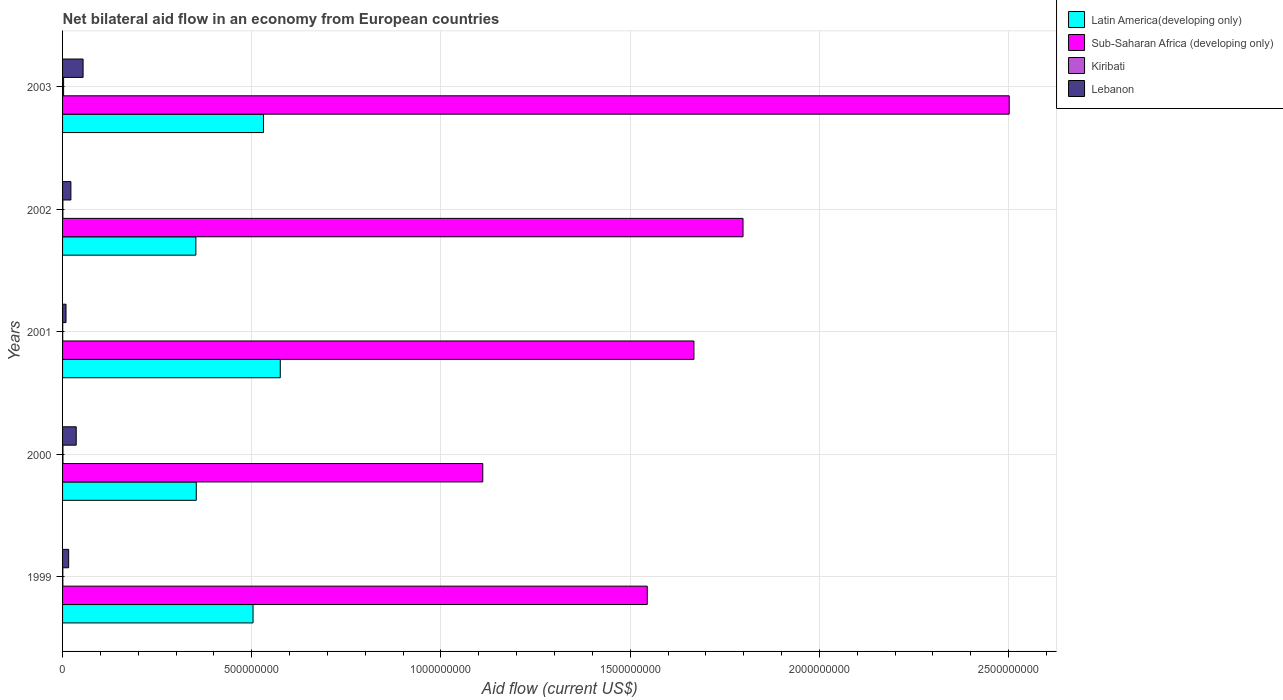How many groups of bars are there?
Make the answer very short. 5. Are the number of bars per tick equal to the number of legend labels?
Keep it short and to the point. Yes. Are the number of bars on each tick of the Y-axis equal?
Your response must be concise. Yes. What is the label of the 1st group of bars from the top?
Your response must be concise. 2003. In how many cases, is the number of bars for a given year not equal to the number of legend labels?
Your answer should be very brief. 0. What is the net bilateral aid flow in Latin America(developing only) in 2003?
Make the answer very short. 5.31e+08. Across all years, what is the maximum net bilateral aid flow in Latin America(developing only)?
Offer a very short reply. 5.75e+08. Across all years, what is the minimum net bilateral aid flow in Latin America(developing only)?
Your response must be concise. 3.52e+08. In which year was the net bilateral aid flow in Kiribati minimum?
Offer a terse response. 2001. What is the total net bilateral aid flow in Kiribati in the graph?
Give a very brief answer. 5.69e+06. What is the difference between the net bilateral aid flow in Latin America(developing only) in 2000 and that in 2002?
Provide a short and direct response. 1.07e+06. What is the difference between the net bilateral aid flow in Lebanon in 1999 and the net bilateral aid flow in Kiribati in 2003?
Ensure brevity in your answer.  1.34e+07. What is the average net bilateral aid flow in Lebanon per year?
Your response must be concise. 2.75e+07. In the year 2002, what is the difference between the net bilateral aid flow in Sub-Saharan Africa (developing only) and net bilateral aid flow in Lebanon?
Keep it short and to the point. 1.78e+09. In how many years, is the net bilateral aid flow in Latin America(developing only) greater than 1400000000 US$?
Provide a short and direct response. 0. What is the ratio of the net bilateral aid flow in Kiribati in 2001 to that in 2002?
Provide a short and direct response. 0.41. Is the net bilateral aid flow in Sub-Saharan Africa (developing only) in 1999 less than that in 2002?
Provide a short and direct response. Yes. What is the difference between the highest and the second highest net bilateral aid flow in Sub-Saharan Africa (developing only)?
Your answer should be very brief. 7.03e+08. What is the difference between the highest and the lowest net bilateral aid flow in Latin America(developing only)?
Offer a terse response. 2.23e+08. In how many years, is the net bilateral aid flow in Kiribati greater than the average net bilateral aid flow in Kiribati taken over all years?
Your response must be concise. 1. What does the 2nd bar from the top in 2000 represents?
Your answer should be very brief. Kiribati. What does the 2nd bar from the bottom in 2003 represents?
Give a very brief answer. Sub-Saharan Africa (developing only). Is it the case that in every year, the sum of the net bilateral aid flow in Sub-Saharan Africa (developing only) and net bilateral aid flow in Latin America(developing only) is greater than the net bilateral aid flow in Lebanon?
Keep it short and to the point. Yes. How many bars are there?
Offer a very short reply. 20. Are all the bars in the graph horizontal?
Provide a short and direct response. Yes. How many years are there in the graph?
Give a very brief answer. 5. What is the difference between two consecutive major ticks on the X-axis?
Make the answer very short. 5.00e+08. Does the graph contain any zero values?
Offer a very short reply. No. How many legend labels are there?
Make the answer very short. 4. What is the title of the graph?
Offer a terse response. Net bilateral aid flow in an economy from European countries. Does "Monaco" appear as one of the legend labels in the graph?
Your answer should be very brief. No. What is the label or title of the Y-axis?
Your answer should be very brief. Years. What is the Aid flow (current US$) of Latin America(developing only) in 1999?
Your response must be concise. 5.03e+08. What is the Aid flow (current US$) in Sub-Saharan Africa (developing only) in 1999?
Offer a very short reply. 1.55e+09. What is the Aid flow (current US$) of Kiribati in 1999?
Keep it short and to the point. 7.50e+05. What is the Aid flow (current US$) of Lebanon in 1999?
Provide a short and direct response. 1.61e+07. What is the Aid flow (current US$) of Latin America(developing only) in 2000?
Your answer should be very brief. 3.53e+08. What is the Aid flow (current US$) of Sub-Saharan Africa (developing only) in 2000?
Provide a succinct answer. 1.11e+09. What is the Aid flow (current US$) of Kiribati in 2000?
Your response must be concise. 1.01e+06. What is the Aid flow (current US$) of Lebanon in 2000?
Provide a short and direct response. 3.61e+07. What is the Aid flow (current US$) in Latin America(developing only) in 2001?
Make the answer very short. 5.75e+08. What is the Aid flow (current US$) in Sub-Saharan Africa (developing only) in 2001?
Your answer should be very brief. 1.67e+09. What is the Aid flow (current US$) in Kiribati in 2001?
Offer a very short reply. 3.50e+05. What is the Aid flow (current US$) in Lebanon in 2001?
Offer a terse response. 9.12e+06. What is the Aid flow (current US$) in Latin America(developing only) in 2002?
Your answer should be compact. 3.52e+08. What is the Aid flow (current US$) of Sub-Saharan Africa (developing only) in 2002?
Ensure brevity in your answer.  1.80e+09. What is the Aid flow (current US$) in Kiribati in 2002?
Your response must be concise. 8.50e+05. What is the Aid flow (current US$) of Lebanon in 2002?
Ensure brevity in your answer.  2.20e+07. What is the Aid flow (current US$) of Latin America(developing only) in 2003?
Offer a very short reply. 5.31e+08. What is the Aid flow (current US$) in Sub-Saharan Africa (developing only) in 2003?
Offer a very short reply. 2.50e+09. What is the Aid flow (current US$) in Kiribati in 2003?
Keep it short and to the point. 2.73e+06. What is the Aid flow (current US$) in Lebanon in 2003?
Provide a succinct answer. 5.43e+07. Across all years, what is the maximum Aid flow (current US$) in Latin America(developing only)?
Keep it short and to the point. 5.75e+08. Across all years, what is the maximum Aid flow (current US$) of Sub-Saharan Africa (developing only)?
Offer a terse response. 2.50e+09. Across all years, what is the maximum Aid flow (current US$) in Kiribati?
Your answer should be compact. 2.73e+06. Across all years, what is the maximum Aid flow (current US$) in Lebanon?
Ensure brevity in your answer.  5.43e+07. Across all years, what is the minimum Aid flow (current US$) in Latin America(developing only)?
Offer a terse response. 3.52e+08. Across all years, what is the minimum Aid flow (current US$) of Sub-Saharan Africa (developing only)?
Your response must be concise. 1.11e+09. Across all years, what is the minimum Aid flow (current US$) of Lebanon?
Provide a short and direct response. 9.12e+06. What is the total Aid flow (current US$) in Latin America(developing only) in the graph?
Provide a succinct answer. 2.32e+09. What is the total Aid flow (current US$) of Sub-Saharan Africa (developing only) in the graph?
Offer a terse response. 8.62e+09. What is the total Aid flow (current US$) of Kiribati in the graph?
Your answer should be very brief. 5.69e+06. What is the total Aid flow (current US$) of Lebanon in the graph?
Make the answer very short. 1.38e+08. What is the difference between the Aid flow (current US$) in Latin America(developing only) in 1999 and that in 2000?
Keep it short and to the point. 1.50e+08. What is the difference between the Aid flow (current US$) of Sub-Saharan Africa (developing only) in 1999 and that in 2000?
Keep it short and to the point. 4.35e+08. What is the difference between the Aid flow (current US$) of Lebanon in 1999 and that in 2000?
Make the answer very short. -2.00e+07. What is the difference between the Aid flow (current US$) of Latin America(developing only) in 1999 and that in 2001?
Your answer should be compact. -7.20e+07. What is the difference between the Aid flow (current US$) of Sub-Saharan Africa (developing only) in 1999 and that in 2001?
Ensure brevity in your answer.  -1.23e+08. What is the difference between the Aid flow (current US$) of Kiribati in 1999 and that in 2001?
Offer a very short reply. 4.00e+05. What is the difference between the Aid flow (current US$) in Lebanon in 1999 and that in 2001?
Your answer should be very brief. 6.97e+06. What is the difference between the Aid flow (current US$) in Latin America(developing only) in 1999 and that in 2002?
Provide a succinct answer. 1.51e+08. What is the difference between the Aid flow (current US$) in Sub-Saharan Africa (developing only) in 1999 and that in 2002?
Your answer should be compact. -2.53e+08. What is the difference between the Aid flow (current US$) in Kiribati in 1999 and that in 2002?
Your response must be concise. -1.00e+05. What is the difference between the Aid flow (current US$) in Lebanon in 1999 and that in 2002?
Keep it short and to the point. -5.90e+06. What is the difference between the Aid flow (current US$) in Latin America(developing only) in 1999 and that in 2003?
Offer a terse response. -2.76e+07. What is the difference between the Aid flow (current US$) of Sub-Saharan Africa (developing only) in 1999 and that in 2003?
Your response must be concise. -9.57e+08. What is the difference between the Aid flow (current US$) of Kiribati in 1999 and that in 2003?
Make the answer very short. -1.98e+06. What is the difference between the Aid flow (current US$) in Lebanon in 1999 and that in 2003?
Provide a short and direct response. -3.82e+07. What is the difference between the Aid flow (current US$) of Latin America(developing only) in 2000 and that in 2001?
Make the answer very short. -2.22e+08. What is the difference between the Aid flow (current US$) of Sub-Saharan Africa (developing only) in 2000 and that in 2001?
Provide a succinct answer. -5.58e+08. What is the difference between the Aid flow (current US$) of Kiribati in 2000 and that in 2001?
Give a very brief answer. 6.60e+05. What is the difference between the Aid flow (current US$) in Lebanon in 2000 and that in 2001?
Your response must be concise. 2.70e+07. What is the difference between the Aid flow (current US$) of Latin America(developing only) in 2000 and that in 2002?
Keep it short and to the point. 1.07e+06. What is the difference between the Aid flow (current US$) of Sub-Saharan Africa (developing only) in 2000 and that in 2002?
Ensure brevity in your answer.  -6.88e+08. What is the difference between the Aid flow (current US$) of Kiribati in 2000 and that in 2002?
Your answer should be very brief. 1.60e+05. What is the difference between the Aid flow (current US$) of Lebanon in 2000 and that in 2002?
Make the answer very short. 1.41e+07. What is the difference between the Aid flow (current US$) of Latin America(developing only) in 2000 and that in 2003?
Your answer should be compact. -1.78e+08. What is the difference between the Aid flow (current US$) in Sub-Saharan Africa (developing only) in 2000 and that in 2003?
Your answer should be compact. -1.39e+09. What is the difference between the Aid flow (current US$) of Kiribati in 2000 and that in 2003?
Make the answer very short. -1.72e+06. What is the difference between the Aid flow (current US$) of Lebanon in 2000 and that in 2003?
Your response must be concise. -1.82e+07. What is the difference between the Aid flow (current US$) in Latin America(developing only) in 2001 and that in 2002?
Make the answer very short. 2.23e+08. What is the difference between the Aid flow (current US$) in Sub-Saharan Africa (developing only) in 2001 and that in 2002?
Give a very brief answer. -1.30e+08. What is the difference between the Aid flow (current US$) in Kiribati in 2001 and that in 2002?
Your answer should be very brief. -5.00e+05. What is the difference between the Aid flow (current US$) of Lebanon in 2001 and that in 2002?
Give a very brief answer. -1.29e+07. What is the difference between the Aid flow (current US$) of Latin America(developing only) in 2001 and that in 2003?
Make the answer very short. 4.44e+07. What is the difference between the Aid flow (current US$) in Sub-Saharan Africa (developing only) in 2001 and that in 2003?
Offer a very short reply. -8.33e+08. What is the difference between the Aid flow (current US$) of Kiribati in 2001 and that in 2003?
Provide a succinct answer. -2.38e+06. What is the difference between the Aid flow (current US$) in Lebanon in 2001 and that in 2003?
Your response must be concise. -4.51e+07. What is the difference between the Aid flow (current US$) of Latin America(developing only) in 2002 and that in 2003?
Your answer should be very brief. -1.79e+08. What is the difference between the Aid flow (current US$) in Sub-Saharan Africa (developing only) in 2002 and that in 2003?
Offer a terse response. -7.03e+08. What is the difference between the Aid flow (current US$) of Kiribati in 2002 and that in 2003?
Keep it short and to the point. -1.88e+06. What is the difference between the Aid flow (current US$) of Lebanon in 2002 and that in 2003?
Give a very brief answer. -3.23e+07. What is the difference between the Aid flow (current US$) in Latin America(developing only) in 1999 and the Aid flow (current US$) in Sub-Saharan Africa (developing only) in 2000?
Provide a short and direct response. -6.07e+08. What is the difference between the Aid flow (current US$) in Latin America(developing only) in 1999 and the Aid flow (current US$) in Kiribati in 2000?
Provide a succinct answer. 5.02e+08. What is the difference between the Aid flow (current US$) of Latin America(developing only) in 1999 and the Aid flow (current US$) of Lebanon in 2000?
Provide a succinct answer. 4.67e+08. What is the difference between the Aid flow (current US$) of Sub-Saharan Africa (developing only) in 1999 and the Aid flow (current US$) of Kiribati in 2000?
Offer a terse response. 1.54e+09. What is the difference between the Aid flow (current US$) in Sub-Saharan Africa (developing only) in 1999 and the Aid flow (current US$) in Lebanon in 2000?
Your answer should be compact. 1.51e+09. What is the difference between the Aid flow (current US$) in Kiribati in 1999 and the Aid flow (current US$) in Lebanon in 2000?
Offer a very short reply. -3.53e+07. What is the difference between the Aid flow (current US$) of Latin America(developing only) in 1999 and the Aid flow (current US$) of Sub-Saharan Africa (developing only) in 2001?
Keep it short and to the point. -1.17e+09. What is the difference between the Aid flow (current US$) in Latin America(developing only) in 1999 and the Aid flow (current US$) in Kiribati in 2001?
Provide a short and direct response. 5.03e+08. What is the difference between the Aid flow (current US$) in Latin America(developing only) in 1999 and the Aid flow (current US$) in Lebanon in 2001?
Offer a very short reply. 4.94e+08. What is the difference between the Aid flow (current US$) of Sub-Saharan Africa (developing only) in 1999 and the Aid flow (current US$) of Kiribati in 2001?
Give a very brief answer. 1.54e+09. What is the difference between the Aid flow (current US$) in Sub-Saharan Africa (developing only) in 1999 and the Aid flow (current US$) in Lebanon in 2001?
Provide a short and direct response. 1.54e+09. What is the difference between the Aid flow (current US$) of Kiribati in 1999 and the Aid flow (current US$) of Lebanon in 2001?
Offer a very short reply. -8.37e+06. What is the difference between the Aid flow (current US$) of Latin America(developing only) in 1999 and the Aid flow (current US$) of Sub-Saharan Africa (developing only) in 2002?
Provide a short and direct response. -1.29e+09. What is the difference between the Aid flow (current US$) of Latin America(developing only) in 1999 and the Aid flow (current US$) of Kiribati in 2002?
Your answer should be compact. 5.03e+08. What is the difference between the Aid flow (current US$) of Latin America(developing only) in 1999 and the Aid flow (current US$) of Lebanon in 2002?
Your answer should be compact. 4.81e+08. What is the difference between the Aid flow (current US$) in Sub-Saharan Africa (developing only) in 1999 and the Aid flow (current US$) in Kiribati in 2002?
Your response must be concise. 1.54e+09. What is the difference between the Aid flow (current US$) in Sub-Saharan Africa (developing only) in 1999 and the Aid flow (current US$) in Lebanon in 2002?
Keep it short and to the point. 1.52e+09. What is the difference between the Aid flow (current US$) in Kiribati in 1999 and the Aid flow (current US$) in Lebanon in 2002?
Offer a terse response. -2.12e+07. What is the difference between the Aid flow (current US$) of Latin America(developing only) in 1999 and the Aid flow (current US$) of Sub-Saharan Africa (developing only) in 2003?
Your response must be concise. -2.00e+09. What is the difference between the Aid flow (current US$) in Latin America(developing only) in 1999 and the Aid flow (current US$) in Kiribati in 2003?
Provide a succinct answer. 5.01e+08. What is the difference between the Aid flow (current US$) of Latin America(developing only) in 1999 and the Aid flow (current US$) of Lebanon in 2003?
Your answer should be very brief. 4.49e+08. What is the difference between the Aid flow (current US$) in Sub-Saharan Africa (developing only) in 1999 and the Aid flow (current US$) in Kiribati in 2003?
Your answer should be compact. 1.54e+09. What is the difference between the Aid flow (current US$) in Sub-Saharan Africa (developing only) in 1999 and the Aid flow (current US$) in Lebanon in 2003?
Provide a short and direct response. 1.49e+09. What is the difference between the Aid flow (current US$) of Kiribati in 1999 and the Aid flow (current US$) of Lebanon in 2003?
Offer a terse response. -5.35e+07. What is the difference between the Aid flow (current US$) of Latin America(developing only) in 2000 and the Aid flow (current US$) of Sub-Saharan Africa (developing only) in 2001?
Provide a succinct answer. -1.32e+09. What is the difference between the Aid flow (current US$) of Latin America(developing only) in 2000 and the Aid flow (current US$) of Kiribati in 2001?
Your answer should be very brief. 3.53e+08. What is the difference between the Aid flow (current US$) in Latin America(developing only) in 2000 and the Aid flow (current US$) in Lebanon in 2001?
Offer a very short reply. 3.44e+08. What is the difference between the Aid flow (current US$) of Sub-Saharan Africa (developing only) in 2000 and the Aid flow (current US$) of Kiribati in 2001?
Ensure brevity in your answer.  1.11e+09. What is the difference between the Aid flow (current US$) of Sub-Saharan Africa (developing only) in 2000 and the Aid flow (current US$) of Lebanon in 2001?
Your answer should be compact. 1.10e+09. What is the difference between the Aid flow (current US$) in Kiribati in 2000 and the Aid flow (current US$) in Lebanon in 2001?
Provide a succinct answer. -8.11e+06. What is the difference between the Aid flow (current US$) of Latin America(developing only) in 2000 and the Aid flow (current US$) of Sub-Saharan Africa (developing only) in 2002?
Your answer should be compact. -1.44e+09. What is the difference between the Aid flow (current US$) in Latin America(developing only) in 2000 and the Aid flow (current US$) in Kiribati in 2002?
Give a very brief answer. 3.53e+08. What is the difference between the Aid flow (current US$) in Latin America(developing only) in 2000 and the Aid flow (current US$) in Lebanon in 2002?
Give a very brief answer. 3.31e+08. What is the difference between the Aid flow (current US$) of Sub-Saharan Africa (developing only) in 2000 and the Aid flow (current US$) of Kiribati in 2002?
Provide a succinct answer. 1.11e+09. What is the difference between the Aid flow (current US$) of Sub-Saharan Africa (developing only) in 2000 and the Aid flow (current US$) of Lebanon in 2002?
Offer a terse response. 1.09e+09. What is the difference between the Aid flow (current US$) of Kiribati in 2000 and the Aid flow (current US$) of Lebanon in 2002?
Offer a very short reply. -2.10e+07. What is the difference between the Aid flow (current US$) in Latin America(developing only) in 2000 and the Aid flow (current US$) in Sub-Saharan Africa (developing only) in 2003?
Keep it short and to the point. -2.15e+09. What is the difference between the Aid flow (current US$) in Latin America(developing only) in 2000 and the Aid flow (current US$) in Kiribati in 2003?
Offer a very short reply. 3.51e+08. What is the difference between the Aid flow (current US$) of Latin America(developing only) in 2000 and the Aid flow (current US$) of Lebanon in 2003?
Your answer should be compact. 2.99e+08. What is the difference between the Aid flow (current US$) in Sub-Saharan Africa (developing only) in 2000 and the Aid flow (current US$) in Kiribati in 2003?
Give a very brief answer. 1.11e+09. What is the difference between the Aid flow (current US$) of Sub-Saharan Africa (developing only) in 2000 and the Aid flow (current US$) of Lebanon in 2003?
Give a very brief answer. 1.06e+09. What is the difference between the Aid flow (current US$) of Kiribati in 2000 and the Aid flow (current US$) of Lebanon in 2003?
Your response must be concise. -5.32e+07. What is the difference between the Aid flow (current US$) in Latin America(developing only) in 2001 and the Aid flow (current US$) in Sub-Saharan Africa (developing only) in 2002?
Offer a very short reply. -1.22e+09. What is the difference between the Aid flow (current US$) in Latin America(developing only) in 2001 and the Aid flow (current US$) in Kiribati in 2002?
Offer a very short reply. 5.75e+08. What is the difference between the Aid flow (current US$) of Latin America(developing only) in 2001 and the Aid flow (current US$) of Lebanon in 2002?
Your answer should be very brief. 5.53e+08. What is the difference between the Aid flow (current US$) of Sub-Saharan Africa (developing only) in 2001 and the Aid flow (current US$) of Kiribati in 2002?
Make the answer very short. 1.67e+09. What is the difference between the Aid flow (current US$) in Sub-Saharan Africa (developing only) in 2001 and the Aid flow (current US$) in Lebanon in 2002?
Make the answer very short. 1.65e+09. What is the difference between the Aid flow (current US$) in Kiribati in 2001 and the Aid flow (current US$) in Lebanon in 2002?
Make the answer very short. -2.16e+07. What is the difference between the Aid flow (current US$) in Latin America(developing only) in 2001 and the Aid flow (current US$) in Sub-Saharan Africa (developing only) in 2003?
Provide a succinct answer. -1.93e+09. What is the difference between the Aid flow (current US$) of Latin America(developing only) in 2001 and the Aid flow (current US$) of Kiribati in 2003?
Your answer should be compact. 5.73e+08. What is the difference between the Aid flow (current US$) of Latin America(developing only) in 2001 and the Aid flow (current US$) of Lebanon in 2003?
Ensure brevity in your answer.  5.21e+08. What is the difference between the Aid flow (current US$) in Sub-Saharan Africa (developing only) in 2001 and the Aid flow (current US$) in Kiribati in 2003?
Offer a terse response. 1.67e+09. What is the difference between the Aid flow (current US$) in Sub-Saharan Africa (developing only) in 2001 and the Aid flow (current US$) in Lebanon in 2003?
Provide a succinct answer. 1.61e+09. What is the difference between the Aid flow (current US$) of Kiribati in 2001 and the Aid flow (current US$) of Lebanon in 2003?
Provide a short and direct response. -5.39e+07. What is the difference between the Aid flow (current US$) in Latin America(developing only) in 2002 and the Aid flow (current US$) in Sub-Saharan Africa (developing only) in 2003?
Your answer should be compact. -2.15e+09. What is the difference between the Aid flow (current US$) in Latin America(developing only) in 2002 and the Aid flow (current US$) in Kiribati in 2003?
Provide a succinct answer. 3.50e+08. What is the difference between the Aid flow (current US$) of Latin America(developing only) in 2002 and the Aid flow (current US$) of Lebanon in 2003?
Your answer should be compact. 2.98e+08. What is the difference between the Aid flow (current US$) of Sub-Saharan Africa (developing only) in 2002 and the Aid flow (current US$) of Kiribati in 2003?
Your response must be concise. 1.80e+09. What is the difference between the Aid flow (current US$) in Sub-Saharan Africa (developing only) in 2002 and the Aid flow (current US$) in Lebanon in 2003?
Your answer should be very brief. 1.74e+09. What is the difference between the Aid flow (current US$) of Kiribati in 2002 and the Aid flow (current US$) of Lebanon in 2003?
Provide a short and direct response. -5.34e+07. What is the average Aid flow (current US$) in Latin America(developing only) per year?
Provide a short and direct response. 4.63e+08. What is the average Aid flow (current US$) of Sub-Saharan Africa (developing only) per year?
Provide a succinct answer. 1.72e+09. What is the average Aid flow (current US$) of Kiribati per year?
Provide a succinct answer. 1.14e+06. What is the average Aid flow (current US$) of Lebanon per year?
Ensure brevity in your answer.  2.75e+07. In the year 1999, what is the difference between the Aid flow (current US$) in Latin America(developing only) and Aid flow (current US$) in Sub-Saharan Africa (developing only)?
Provide a succinct answer. -1.04e+09. In the year 1999, what is the difference between the Aid flow (current US$) of Latin America(developing only) and Aid flow (current US$) of Kiribati?
Your answer should be compact. 5.03e+08. In the year 1999, what is the difference between the Aid flow (current US$) in Latin America(developing only) and Aid flow (current US$) in Lebanon?
Give a very brief answer. 4.87e+08. In the year 1999, what is the difference between the Aid flow (current US$) in Sub-Saharan Africa (developing only) and Aid flow (current US$) in Kiribati?
Provide a succinct answer. 1.54e+09. In the year 1999, what is the difference between the Aid flow (current US$) in Sub-Saharan Africa (developing only) and Aid flow (current US$) in Lebanon?
Give a very brief answer. 1.53e+09. In the year 1999, what is the difference between the Aid flow (current US$) of Kiribati and Aid flow (current US$) of Lebanon?
Your response must be concise. -1.53e+07. In the year 2000, what is the difference between the Aid flow (current US$) in Latin America(developing only) and Aid flow (current US$) in Sub-Saharan Africa (developing only)?
Make the answer very short. -7.57e+08. In the year 2000, what is the difference between the Aid flow (current US$) of Latin America(developing only) and Aid flow (current US$) of Kiribati?
Provide a short and direct response. 3.52e+08. In the year 2000, what is the difference between the Aid flow (current US$) in Latin America(developing only) and Aid flow (current US$) in Lebanon?
Your answer should be very brief. 3.17e+08. In the year 2000, what is the difference between the Aid flow (current US$) of Sub-Saharan Africa (developing only) and Aid flow (current US$) of Kiribati?
Make the answer very short. 1.11e+09. In the year 2000, what is the difference between the Aid flow (current US$) of Sub-Saharan Africa (developing only) and Aid flow (current US$) of Lebanon?
Offer a very short reply. 1.07e+09. In the year 2000, what is the difference between the Aid flow (current US$) of Kiribati and Aid flow (current US$) of Lebanon?
Your response must be concise. -3.51e+07. In the year 2001, what is the difference between the Aid flow (current US$) of Latin America(developing only) and Aid flow (current US$) of Sub-Saharan Africa (developing only)?
Keep it short and to the point. -1.09e+09. In the year 2001, what is the difference between the Aid flow (current US$) in Latin America(developing only) and Aid flow (current US$) in Kiribati?
Provide a succinct answer. 5.75e+08. In the year 2001, what is the difference between the Aid flow (current US$) of Latin America(developing only) and Aid flow (current US$) of Lebanon?
Offer a very short reply. 5.66e+08. In the year 2001, what is the difference between the Aid flow (current US$) of Sub-Saharan Africa (developing only) and Aid flow (current US$) of Kiribati?
Keep it short and to the point. 1.67e+09. In the year 2001, what is the difference between the Aid flow (current US$) of Sub-Saharan Africa (developing only) and Aid flow (current US$) of Lebanon?
Your response must be concise. 1.66e+09. In the year 2001, what is the difference between the Aid flow (current US$) of Kiribati and Aid flow (current US$) of Lebanon?
Give a very brief answer. -8.77e+06. In the year 2002, what is the difference between the Aid flow (current US$) of Latin America(developing only) and Aid flow (current US$) of Sub-Saharan Africa (developing only)?
Your answer should be compact. -1.45e+09. In the year 2002, what is the difference between the Aid flow (current US$) in Latin America(developing only) and Aid flow (current US$) in Kiribati?
Your answer should be very brief. 3.51e+08. In the year 2002, what is the difference between the Aid flow (current US$) of Latin America(developing only) and Aid flow (current US$) of Lebanon?
Provide a short and direct response. 3.30e+08. In the year 2002, what is the difference between the Aid flow (current US$) of Sub-Saharan Africa (developing only) and Aid flow (current US$) of Kiribati?
Offer a very short reply. 1.80e+09. In the year 2002, what is the difference between the Aid flow (current US$) in Sub-Saharan Africa (developing only) and Aid flow (current US$) in Lebanon?
Keep it short and to the point. 1.78e+09. In the year 2002, what is the difference between the Aid flow (current US$) of Kiribati and Aid flow (current US$) of Lebanon?
Offer a terse response. -2.11e+07. In the year 2003, what is the difference between the Aid flow (current US$) in Latin America(developing only) and Aid flow (current US$) in Sub-Saharan Africa (developing only)?
Give a very brief answer. -1.97e+09. In the year 2003, what is the difference between the Aid flow (current US$) in Latin America(developing only) and Aid flow (current US$) in Kiribati?
Ensure brevity in your answer.  5.28e+08. In the year 2003, what is the difference between the Aid flow (current US$) of Latin America(developing only) and Aid flow (current US$) of Lebanon?
Keep it short and to the point. 4.77e+08. In the year 2003, what is the difference between the Aid flow (current US$) in Sub-Saharan Africa (developing only) and Aid flow (current US$) in Kiribati?
Provide a succinct answer. 2.50e+09. In the year 2003, what is the difference between the Aid flow (current US$) in Sub-Saharan Africa (developing only) and Aid flow (current US$) in Lebanon?
Keep it short and to the point. 2.45e+09. In the year 2003, what is the difference between the Aid flow (current US$) in Kiribati and Aid flow (current US$) in Lebanon?
Give a very brief answer. -5.15e+07. What is the ratio of the Aid flow (current US$) of Latin America(developing only) in 1999 to that in 2000?
Give a very brief answer. 1.42. What is the ratio of the Aid flow (current US$) in Sub-Saharan Africa (developing only) in 1999 to that in 2000?
Offer a terse response. 1.39. What is the ratio of the Aid flow (current US$) of Kiribati in 1999 to that in 2000?
Provide a short and direct response. 0.74. What is the ratio of the Aid flow (current US$) of Lebanon in 1999 to that in 2000?
Your answer should be very brief. 0.45. What is the ratio of the Aid flow (current US$) of Latin America(developing only) in 1999 to that in 2001?
Give a very brief answer. 0.87. What is the ratio of the Aid flow (current US$) in Sub-Saharan Africa (developing only) in 1999 to that in 2001?
Make the answer very short. 0.93. What is the ratio of the Aid flow (current US$) of Kiribati in 1999 to that in 2001?
Offer a very short reply. 2.14. What is the ratio of the Aid flow (current US$) of Lebanon in 1999 to that in 2001?
Ensure brevity in your answer.  1.76. What is the ratio of the Aid flow (current US$) in Latin America(developing only) in 1999 to that in 2002?
Give a very brief answer. 1.43. What is the ratio of the Aid flow (current US$) in Sub-Saharan Africa (developing only) in 1999 to that in 2002?
Your answer should be very brief. 0.86. What is the ratio of the Aid flow (current US$) of Kiribati in 1999 to that in 2002?
Your answer should be very brief. 0.88. What is the ratio of the Aid flow (current US$) in Lebanon in 1999 to that in 2002?
Keep it short and to the point. 0.73. What is the ratio of the Aid flow (current US$) in Latin America(developing only) in 1999 to that in 2003?
Ensure brevity in your answer.  0.95. What is the ratio of the Aid flow (current US$) of Sub-Saharan Africa (developing only) in 1999 to that in 2003?
Make the answer very short. 0.62. What is the ratio of the Aid flow (current US$) in Kiribati in 1999 to that in 2003?
Your response must be concise. 0.27. What is the ratio of the Aid flow (current US$) of Lebanon in 1999 to that in 2003?
Your response must be concise. 0.3. What is the ratio of the Aid flow (current US$) of Latin America(developing only) in 2000 to that in 2001?
Keep it short and to the point. 0.61. What is the ratio of the Aid flow (current US$) in Sub-Saharan Africa (developing only) in 2000 to that in 2001?
Ensure brevity in your answer.  0.67. What is the ratio of the Aid flow (current US$) in Kiribati in 2000 to that in 2001?
Offer a very short reply. 2.89. What is the ratio of the Aid flow (current US$) in Lebanon in 2000 to that in 2001?
Make the answer very short. 3.96. What is the ratio of the Aid flow (current US$) of Latin America(developing only) in 2000 to that in 2002?
Give a very brief answer. 1. What is the ratio of the Aid flow (current US$) in Sub-Saharan Africa (developing only) in 2000 to that in 2002?
Offer a very short reply. 0.62. What is the ratio of the Aid flow (current US$) in Kiribati in 2000 to that in 2002?
Offer a terse response. 1.19. What is the ratio of the Aid flow (current US$) of Lebanon in 2000 to that in 2002?
Provide a short and direct response. 1.64. What is the ratio of the Aid flow (current US$) in Latin America(developing only) in 2000 to that in 2003?
Provide a short and direct response. 0.67. What is the ratio of the Aid flow (current US$) in Sub-Saharan Africa (developing only) in 2000 to that in 2003?
Offer a terse response. 0.44. What is the ratio of the Aid flow (current US$) in Kiribati in 2000 to that in 2003?
Give a very brief answer. 0.37. What is the ratio of the Aid flow (current US$) in Lebanon in 2000 to that in 2003?
Make the answer very short. 0.66. What is the ratio of the Aid flow (current US$) in Latin America(developing only) in 2001 to that in 2002?
Provide a short and direct response. 1.63. What is the ratio of the Aid flow (current US$) in Sub-Saharan Africa (developing only) in 2001 to that in 2002?
Your response must be concise. 0.93. What is the ratio of the Aid flow (current US$) of Kiribati in 2001 to that in 2002?
Your answer should be very brief. 0.41. What is the ratio of the Aid flow (current US$) of Lebanon in 2001 to that in 2002?
Your response must be concise. 0.41. What is the ratio of the Aid flow (current US$) of Latin America(developing only) in 2001 to that in 2003?
Offer a very short reply. 1.08. What is the ratio of the Aid flow (current US$) in Sub-Saharan Africa (developing only) in 2001 to that in 2003?
Your answer should be very brief. 0.67. What is the ratio of the Aid flow (current US$) in Kiribati in 2001 to that in 2003?
Provide a succinct answer. 0.13. What is the ratio of the Aid flow (current US$) of Lebanon in 2001 to that in 2003?
Provide a succinct answer. 0.17. What is the ratio of the Aid flow (current US$) in Latin America(developing only) in 2002 to that in 2003?
Give a very brief answer. 0.66. What is the ratio of the Aid flow (current US$) in Sub-Saharan Africa (developing only) in 2002 to that in 2003?
Your response must be concise. 0.72. What is the ratio of the Aid flow (current US$) in Kiribati in 2002 to that in 2003?
Your response must be concise. 0.31. What is the ratio of the Aid flow (current US$) in Lebanon in 2002 to that in 2003?
Provide a succinct answer. 0.41. What is the difference between the highest and the second highest Aid flow (current US$) in Latin America(developing only)?
Provide a short and direct response. 4.44e+07. What is the difference between the highest and the second highest Aid flow (current US$) of Sub-Saharan Africa (developing only)?
Ensure brevity in your answer.  7.03e+08. What is the difference between the highest and the second highest Aid flow (current US$) of Kiribati?
Provide a short and direct response. 1.72e+06. What is the difference between the highest and the second highest Aid flow (current US$) of Lebanon?
Your response must be concise. 1.82e+07. What is the difference between the highest and the lowest Aid flow (current US$) in Latin America(developing only)?
Keep it short and to the point. 2.23e+08. What is the difference between the highest and the lowest Aid flow (current US$) in Sub-Saharan Africa (developing only)?
Provide a short and direct response. 1.39e+09. What is the difference between the highest and the lowest Aid flow (current US$) in Kiribati?
Offer a very short reply. 2.38e+06. What is the difference between the highest and the lowest Aid flow (current US$) in Lebanon?
Offer a terse response. 4.51e+07. 